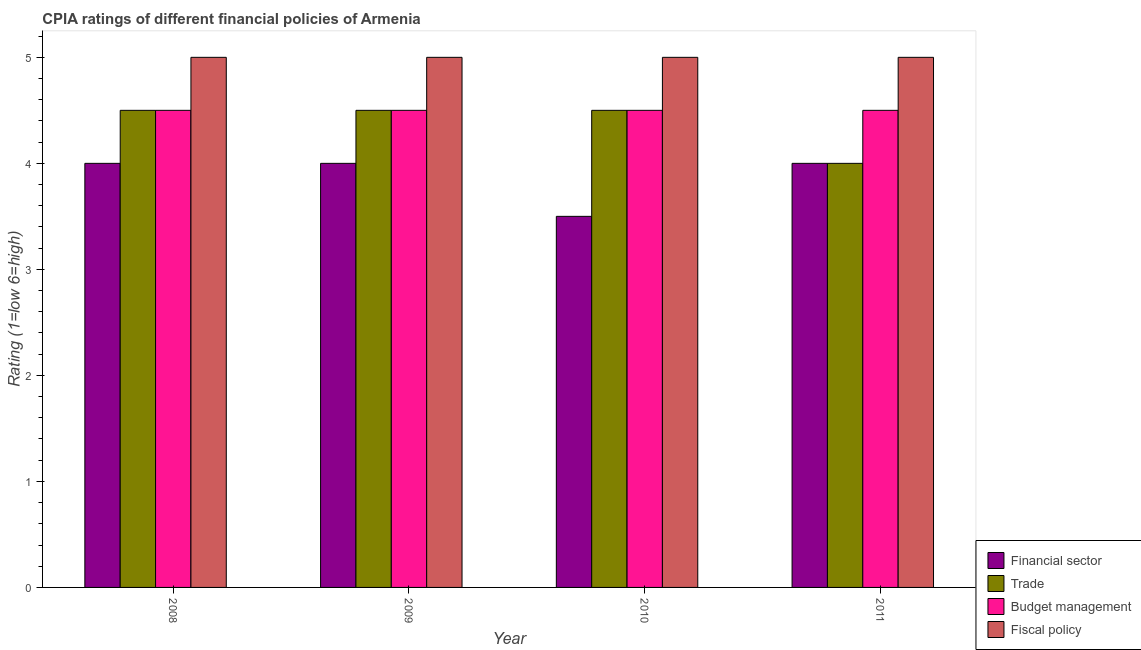How many groups of bars are there?
Offer a terse response. 4. How many bars are there on the 4th tick from the left?
Keep it short and to the point. 4. What is the label of the 1st group of bars from the left?
Your answer should be compact. 2008. Across all years, what is the maximum cpia rating of fiscal policy?
Offer a very short reply. 5. In which year was the cpia rating of trade minimum?
Give a very brief answer. 2011. What is the total cpia rating of financial sector in the graph?
Provide a succinct answer. 15.5. What is the difference between the cpia rating of trade in 2009 and the cpia rating of fiscal policy in 2011?
Offer a terse response. 0.5. What is the ratio of the cpia rating of trade in 2008 to that in 2009?
Keep it short and to the point. 1. Is the cpia rating of budget management in 2008 less than that in 2011?
Your answer should be very brief. No. What is the difference between the highest and the second highest cpia rating of trade?
Provide a succinct answer. 0. What is the difference between the highest and the lowest cpia rating of fiscal policy?
Provide a short and direct response. 0. Is the sum of the cpia rating of financial sector in 2010 and 2011 greater than the maximum cpia rating of budget management across all years?
Keep it short and to the point. Yes. What does the 3rd bar from the left in 2009 represents?
Make the answer very short. Budget management. What does the 2nd bar from the right in 2008 represents?
Keep it short and to the point. Budget management. Is it the case that in every year, the sum of the cpia rating of financial sector and cpia rating of trade is greater than the cpia rating of budget management?
Ensure brevity in your answer.  Yes. What is the difference between two consecutive major ticks on the Y-axis?
Provide a short and direct response. 1. Are the values on the major ticks of Y-axis written in scientific E-notation?
Your answer should be compact. No. Where does the legend appear in the graph?
Offer a very short reply. Bottom right. How many legend labels are there?
Keep it short and to the point. 4. How are the legend labels stacked?
Provide a succinct answer. Vertical. What is the title of the graph?
Provide a succinct answer. CPIA ratings of different financial policies of Armenia. What is the label or title of the X-axis?
Make the answer very short. Year. What is the label or title of the Y-axis?
Make the answer very short. Rating (1=low 6=high). What is the Rating (1=low 6=high) of Trade in 2008?
Your response must be concise. 4.5. What is the Rating (1=low 6=high) in Trade in 2009?
Make the answer very short. 4.5. What is the Rating (1=low 6=high) in Budget management in 2009?
Make the answer very short. 4.5. What is the Rating (1=low 6=high) of Financial sector in 2010?
Offer a very short reply. 3.5. What is the Rating (1=low 6=high) in Trade in 2010?
Keep it short and to the point. 4.5. Across all years, what is the maximum Rating (1=low 6=high) in Fiscal policy?
Offer a very short reply. 5. Across all years, what is the minimum Rating (1=low 6=high) of Budget management?
Provide a short and direct response. 4.5. What is the total Rating (1=low 6=high) of Financial sector in the graph?
Make the answer very short. 15.5. What is the total Rating (1=low 6=high) in Trade in the graph?
Your response must be concise. 17.5. What is the total Rating (1=low 6=high) of Fiscal policy in the graph?
Your answer should be very brief. 20. What is the difference between the Rating (1=low 6=high) in Financial sector in 2008 and that in 2009?
Ensure brevity in your answer.  0. What is the difference between the Rating (1=low 6=high) of Budget management in 2008 and that in 2009?
Your answer should be very brief. 0. What is the difference between the Rating (1=low 6=high) in Fiscal policy in 2008 and that in 2010?
Make the answer very short. 0. What is the difference between the Rating (1=low 6=high) of Financial sector in 2008 and that in 2011?
Provide a succinct answer. 0. What is the difference between the Rating (1=low 6=high) of Budget management in 2008 and that in 2011?
Offer a terse response. 0. What is the difference between the Rating (1=low 6=high) of Financial sector in 2009 and that in 2010?
Your answer should be compact. 0.5. What is the difference between the Rating (1=low 6=high) in Trade in 2009 and that in 2010?
Provide a short and direct response. 0. What is the difference between the Rating (1=low 6=high) in Budget management in 2009 and that in 2010?
Your answer should be compact. 0. What is the difference between the Rating (1=low 6=high) in Financial sector in 2009 and that in 2011?
Give a very brief answer. 0. What is the difference between the Rating (1=low 6=high) of Budget management in 2009 and that in 2011?
Make the answer very short. 0. What is the difference between the Rating (1=low 6=high) in Financial sector in 2010 and that in 2011?
Make the answer very short. -0.5. What is the difference between the Rating (1=low 6=high) in Budget management in 2010 and that in 2011?
Make the answer very short. 0. What is the difference between the Rating (1=low 6=high) in Financial sector in 2008 and the Rating (1=low 6=high) in Trade in 2009?
Provide a succinct answer. -0.5. What is the difference between the Rating (1=low 6=high) in Financial sector in 2008 and the Rating (1=low 6=high) in Budget management in 2009?
Your answer should be very brief. -0.5. What is the difference between the Rating (1=low 6=high) of Financial sector in 2008 and the Rating (1=low 6=high) of Fiscal policy in 2009?
Your answer should be compact. -1. What is the difference between the Rating (1=low 6=high) of Trade in 2008 and the Rating (1=low 6=high) of Budget management in 2009?
Your answer should be very brief. 0. What is the difference between the Rating (1=low 6=high) in Trade in 2008 and the Rating (1=low 6=high) in Fiscal policy in 2009?
Your response must be concise. -0.5. What is the difference between the Rating (1=low 6=high) in Financial sector in 2008 and the Rating (1=low 6=high) in Trade in 2010?
Give a very brief answer. -0.5. What is the difference between the Rating (1=low 6=high) of Budget management in 2008 and the Rating (1=low 6=high) of Fiscal policy in 2010?
Your answer should be very brief. -0.5. What is the difference between the Rating (1=low 6=high) in Financial sector in 2008 and the Rating (1=low 6=high) in Trade in 2011?
Offer a very short reply. 0. What is the difference between the Rating (1=low 6=high) in Financial sector in 2008 and the Rating (1=low 6=high) in Budget management in 2011?
Make the answer very short. -0.5. What is the difference between the Rating (1=low 6=high) of Financial sector in 2008 and the Rating (1=low 6=high) of Fiscal policy in 2011?
Keep it short and to the point. -1. What is the difference between the Rating (1=low 6=high) in Trade in 2008 and the Rating (1=low 6=high) in Fiscal policy in 2011?
Give a very brief answer. -0.5. What is the difference between the Rating (1=low 6=high) in Budget management in 2009 and the Rating (1=low 6=high) in Fiscal policy in 2010?
Provide a short and direct response. -0.5. What is the difference between the Rating (1=low 6=high) of Financial sector in 2009 and the Rating (1=low 6=high) of Trade in 2011?
Make the answer very short. 0. What is the difference between the Rating (1=low 6=high) in Financial sector in 2009 and the Rating (1=low 6=high) in Budget management in 2011?
Offer a very short reply. -0.5. What is the difference between the Rating (1=low 6=high) of Financial sector in 2009 and the Rating (1=low 6=high) of Fiscal policy in 2011?
Your answer should be compact. -1. What is the difference between the Rating (1=low 6=high) in Trade in 2009 and the Rating (1=low 6=high) in Fiscal policy in 2011?
Offer a terse response. -0.5. What is the difference between the Rating (1=low 6=high) in Financial sector in 2010 and the Rating (1=low 6=high) in Trade in 2011?
Your response must be concise. -0.5. What is the difference between the Rating (1=low 6=high) in Financial sector in 2010 and the Rating (1=low 6=high) in Fiscal policy in 2011?
Provide a short and direct response. -1.5. What is the difference between the Rating (1=low 6=high) in Budget management in 2010 and the Rating (1=low 6=high) in Fiscal policy in 2011?
Your response must be concise. -0.5. What is the average Rating (1=low 6=high) of Financial sector per year?
Give a very brief answer. 3.88. What is the average Rating (1=low 6=high) in Trade per year?
Make the answer very short. 4.38. In the year 2008, what is the difference between the Rating (1=low 6=high) of Financial sector and Rating (1=low 6=high) of Trade?
Your answer should be very brief. -0.5. In the year 2008, what is the difference between the Rating (1=low 6=high) of Financial sector and Rating (1=low 6=high) of Budget management?
Your answer should be compact. -0.5. In the year 2008, what is the difference between the Rating (1=low 6=high) of Financial sector and Rating (1=low 6=high) of Fiscal policy?
Your response must be concise. -1. In the year 2008, what is the difference between the Rating (1=low 6=high) of Trade and Rating (1=low 6=high) of Budget management?
Your response must be concise. 0. In the year 2008, what is the difference between the Rating (1=low 6=high) of Trade and Rating (1=low 6=high) of Fiscal policy?
Your answer should be very brief. -0.5. In the year 2008, what is the difference between the Rating (1=low 6=high) in Budget management and Rating (1=low 6=high) in Fiscal policy?
Your answer should be very brief. -0.5. In the year 2009, what is the difference between the Rating (1=low 6=high) of Financial sector and Rating (1=low 6=high) of Trade?
Keep it short and to the point. -0.5. In the year 2009, what is the difference between the Rating (1=low 6=high) of Trade and Rating (1=low 6=high) of Budget management?
Your answer should be compact. 0. In the year 2009, what is the difference between the Rating (1=low 6=high) in Trade and Rating (1=low 6=high) in Fiscal policy?
Give a very brief answer. -0.5. In the year 2010, what is the difference between the Rating (1=low 6=high) in Financial sector and Rating (1=low 6=high) in Fiscal policy?
Provide a succinct answer. -1.5. In the year 2010, what is the difference between the Rating (1=low 6=high) of Budget management and Rating (1=low 6=high) of Fiscal policy?
Your answer should be compact. -0.5. In the year 2011, what is the difference between the Rating (1=low 6=high) in Financial sector and Rating (1=low 6=high) in Budget management?
Your answer should be very brief. -0.5. In the year 2011, what is the difference between the Rating (1=low 6=high) in Trade and Rating (1=low 6=high) in Fiscal policy?
Your answer should be very brief. -1. What is the ratio of the Rating (1=low 6=high) of Financial sector in 2008 to that in 2009?
Make the answer very short. 1. What is the ratio of the Rating (1=low 6=high) in Trade in 2008 to that in 2009?
Give a very brief answer. 1. What is the ratio of the Rating (1=low 6=high) in Fiscal policy in 2008 to that in 2009?
Make the answer very short. 1. What is the ratio of the Rating (1=low 6=high) in Financial sector in 2008 to that in 2010?
Provide a short and direct response. 1.14. What is the ratio of the Rating (1=low 6=high) of Trade in 2008 to that in 2010?
Offer a very short reply. 1. What is the ratio of the Rating (1=low 6=high) in Budget management in 2008 to that in 2010?
Provide a succinct answer. 1. What is the ratio of the Rating (1=low 6=high) of Trade in 2009 to that in 2010?
Give a very brief answer. 1. What is the ratio of the Rating (1=low 6=high) in Trade in 2009 to that in 2011?
Your answer should be compact. 1.12. What is the ratio of the Rating (1=low 6=high) in Budget management in 2009 to that in 2011?
Make the answer very short. 1. What is the ratio of the Rating (1=low 6=high) of Budget management in 2010 to that in 2011?
Make the answer very short. 1. What is the ratio of the Rating (1=low 6=high) of Fiscal policy in 2010 to that in 2011?
Make the answer very short. 1. What is the difference between the highest and the second highest Rating (1=low 6=high) of Financial sector?
Ensure brevity in your answer.  0. What is the difference between the highest and the second highest Rating (1=low 6=high) in Trade?
Make the answer very short. 0. What is the difference between the highest and the second highest Rating (1=low 6=high) in Budget management?
Give a very brief answer. 0. What is the difference between the highest and the second highest Rating (1=low 6=high) of Fiscal policy?
Give a very brief answer. 0. What is the difference between the highest and the lowest Rating (1=low 6=high) of Financial sector?
Make the answer very short. 0.5. What is the difference between the highest and the lowest Rating (1=low 6=high) of Budget management?
Offer a very short reply. 0. 